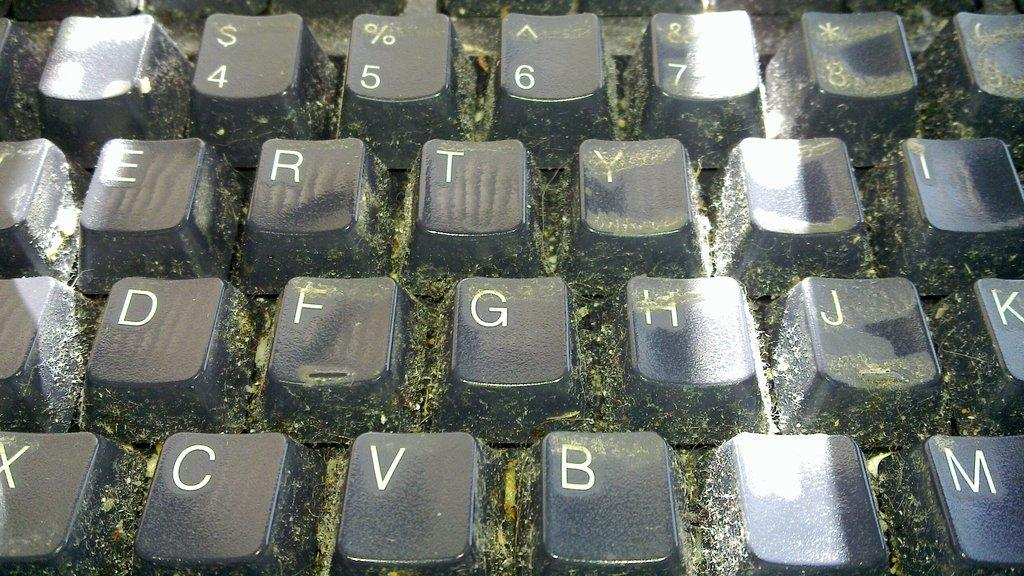<image>
Provide a brief description of the given image. A close up of a keyboard with grass under the letters, the letter G is visible. 